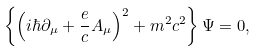Convert formula to latex. <formula><loc_0><loc_0><loc_500><loc_500>\left \{ \left ( i \hbar { \partial } _ { \mu } + \frac { e } { c } A _ { \mu } \right ) ^ { 2 } + m ^ { 2 } c ^ { 2 } \right \} \Psi = 0 ,</formula> 